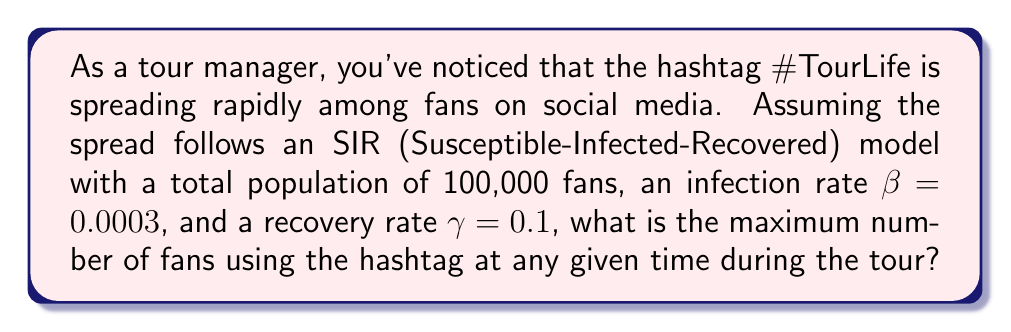Solve this math problem. To solve this problem, we'll use the SIR model and find the maximum number of "infected" (I) individuals, which represents fans actively using the hashtag.

Step 1: Recall the SIR model equations:
$$\frac{dS}{dt} = -\beta SI$$
$$\frac{dI}{dt} = \beta SI - \gamma I$$
$$\frac{dR}{dt} = \gamma I$$

Step 2: The maximum number of infected occurs when $\frac{dI}{dt} = 0$. At this point:
$$0 = \beta SI - \gamma I$$
$$\beta S = \gamma$$

Step 3: Express S in terms of the total population N and I:
$$S = N - I - R$$

Step 4: At the peak of infection, R can be approximated as:
$$R \approx \frac{\gamma}{\beta}(\ln(N) - \ln(\frac{\gamma}{\beta}))$$

Step 5: Substitute this into the equation for S:
$$N - I - \frac{\gamma}{\beta}(\ln(N) - \ln(\frac{\gamma}{\beta})) = \frac{\gamma}{\beta}$$

Step 6: Solve for I:
$$I = N - \frac{\gamma}{\beta} - \frac{\gamma}{\beta}(\ln(N) - \ln(\frac{\gamma}{\beta}))$$

Step 7: Insert the given values:
$$I = 100000 - \frac{0.1}{0.0003} - \frac{0.1}{0.0003}(\ln(100000) - \ln(\frac{0.1}{0.0003}))$$

Step 8: Calculate the result:
$$I \approx 63,212$$

Therefore, the maximum number of fans using the hashtag at any given time is approximately 63,212.
Answer: 63,212 fans 